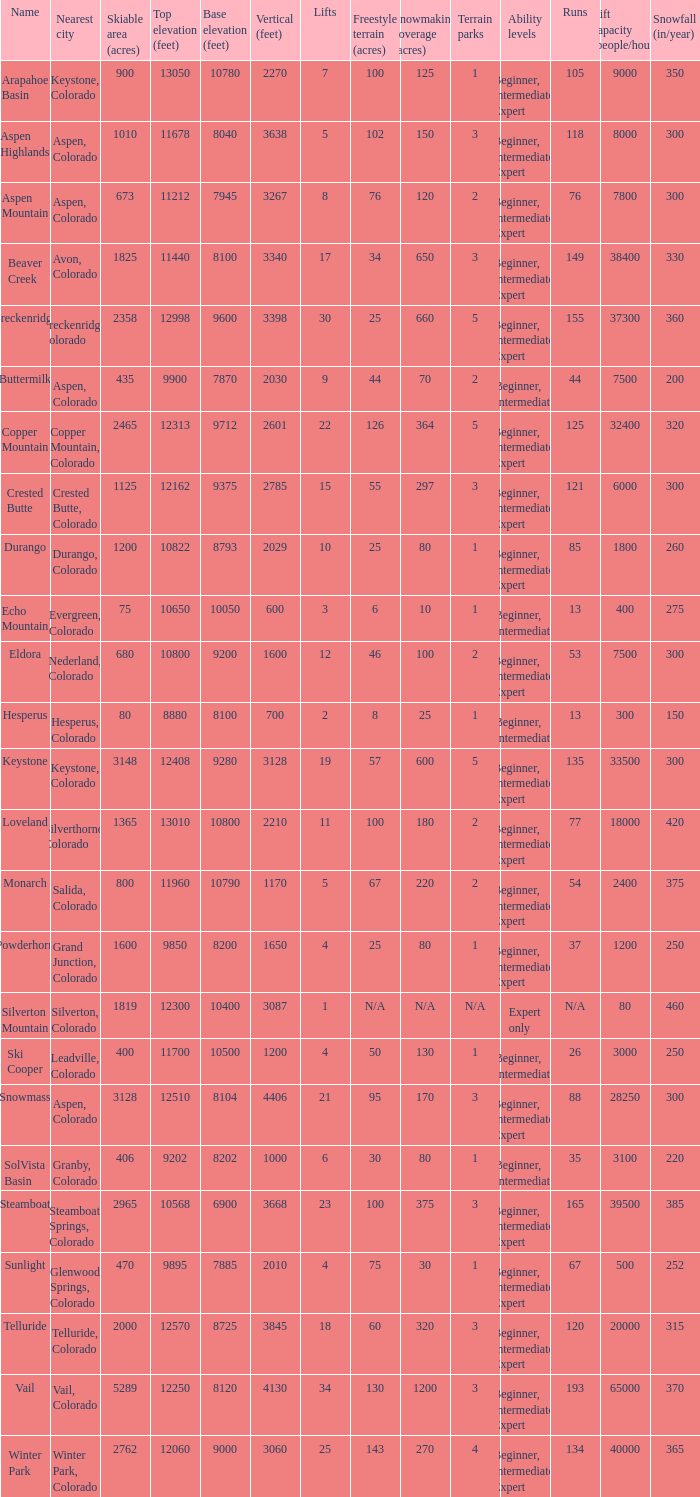If there are 11 lifts, what is the base elevation? 10800.0. 